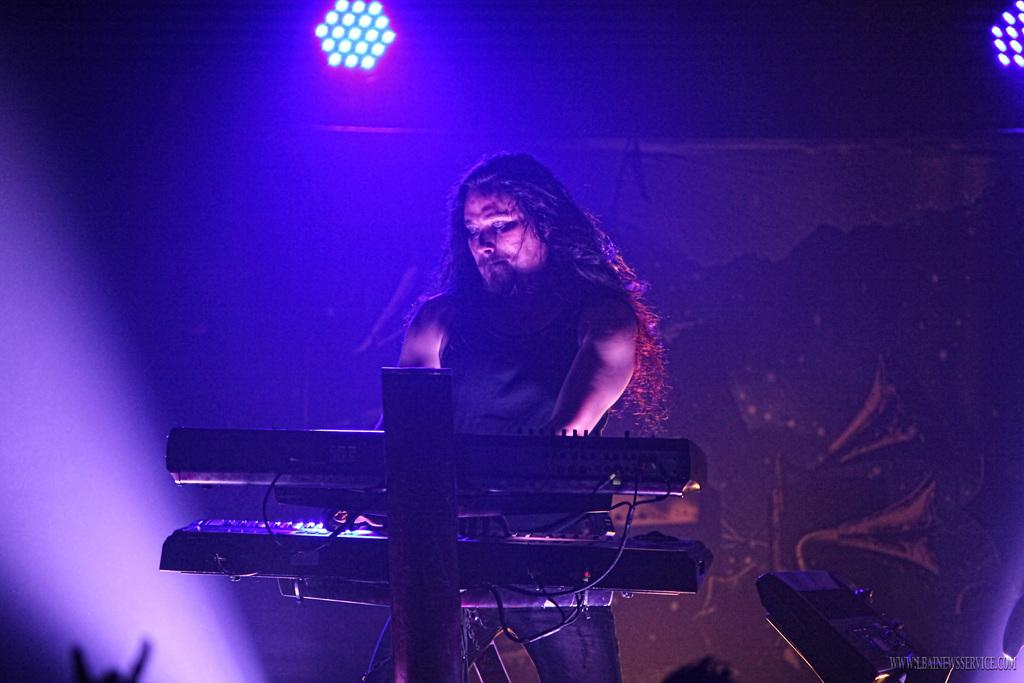What is the man in the image doing? The man is playing a piano in the image. Can you describe the setting of the image? There is a light in the background of the image. What color is the eye of the quarter in the image? There is no quarter or eye present in the image; it features a man playing a piano and a light in the background. 